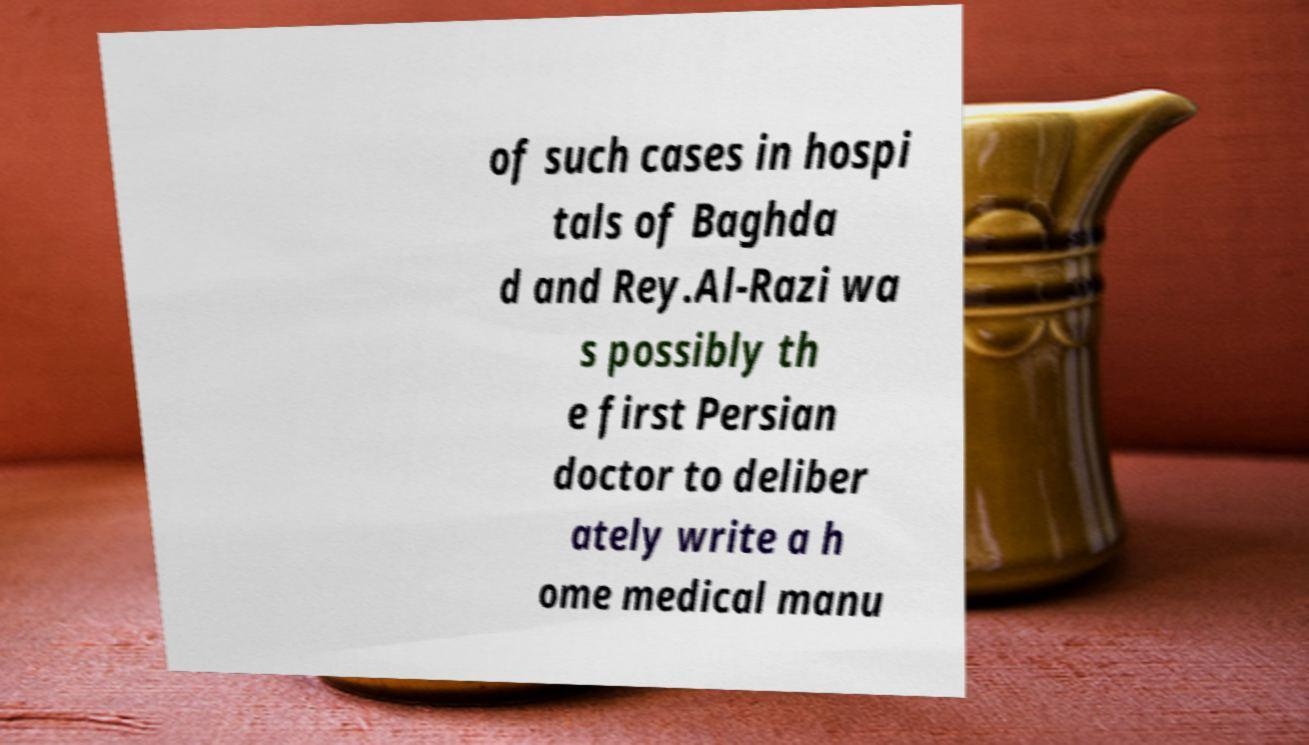There's text embedded in this image that I need extracted. Can you transcribe it verbatim? of such cases in hospi tals of Baghda d and Rey.Al-Razi wa s possibly th e first Persian doctor to deliber ately write a h ome medical manu 